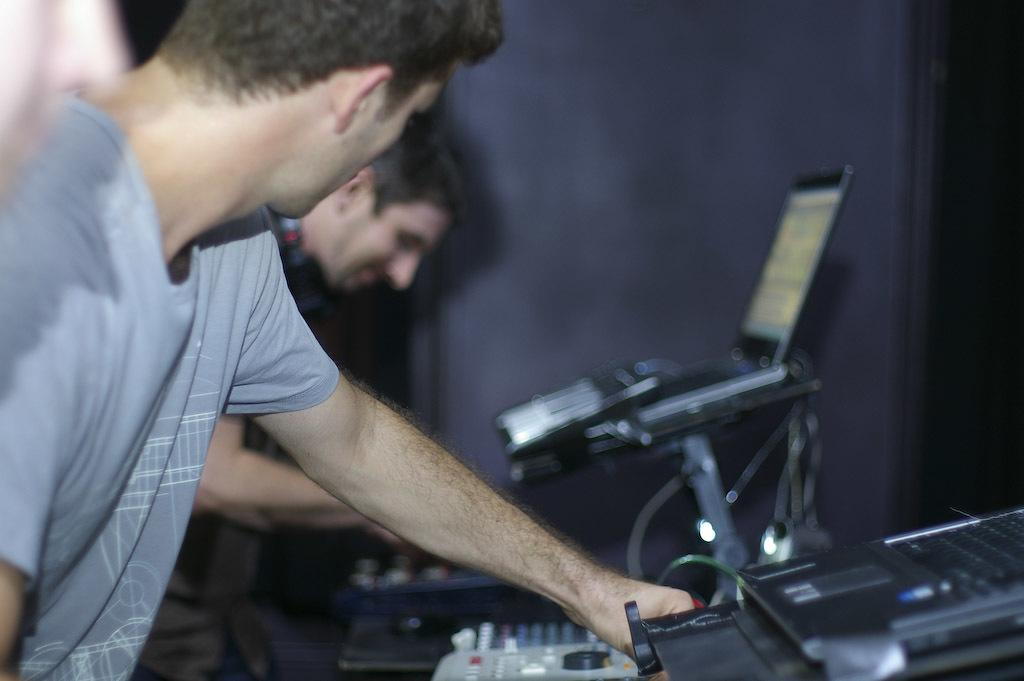How many people are present in the image? There are persons in the image, but the exact number is not specified. What are the persons doing in the image? The persons are likely playing musical instruments, as they are mentioned in the facts. What other objects can be seen in the image? Laptops are also present in the image. What is visible in the background of the image? There is a wall in the background of the image. What type of fan is visible in the image? There is no fan present in the image. How does the stew taste in the image? There is no stew present in the image. 